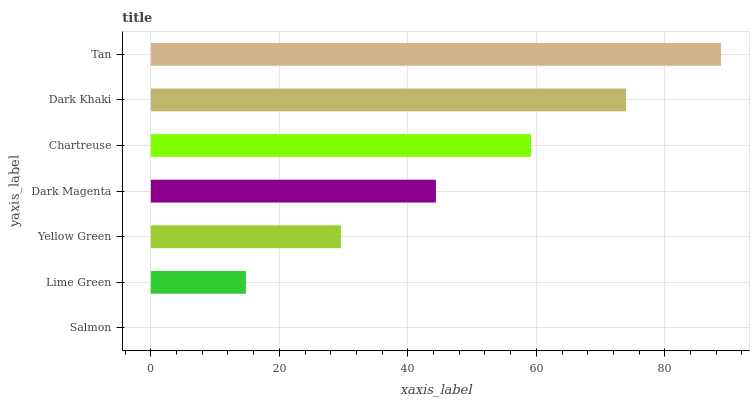Is Salmon the minimum?
Answer yes or no. Yes. Is Tan the maximum?
Answer yes or no. Yes. Is Lime Green the minimum?
Answer yes or no. No. Is Lime Green the maximum?
Answer yes or no. No. Is Lime Green greater than Salmon?
Answer yes or no. Yes. Is Salmon less than Lime Green?
Answer yes or no. Yes. Is Salmon greater than Lime Green?
Answer yes or no. No. Is Lime Green less than Salmon?
Answer yes or no. No. Is Dark Magenta the high median?
Answer yes or no. Yes. Is Dark Magenta the low median?
Answer yes or no. Yes. Is Chartreuse the high median?
Answer yes or no. No. Is Dark Khaki the low median?
Answer yes or no. No. 